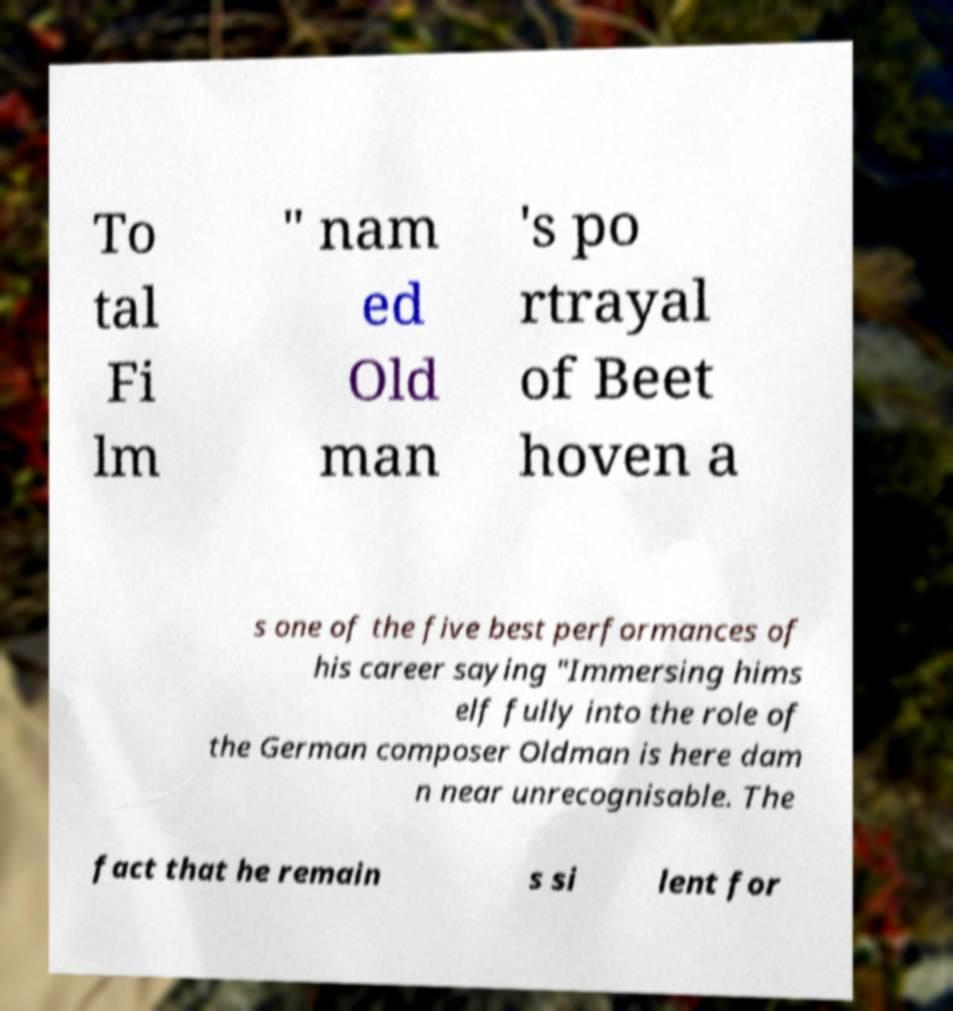For documentation purposes, I need the text within this image transcribed. Could you provide that? To tal Fi lm " nam ed Old man 's po rtrayal of Beet hoven a s one of the five best performances of his career saying "Immersing hims elf fully into the role of the German composer Oldman is here dam n near unrecognisable. The fact that he remain s si lent for 